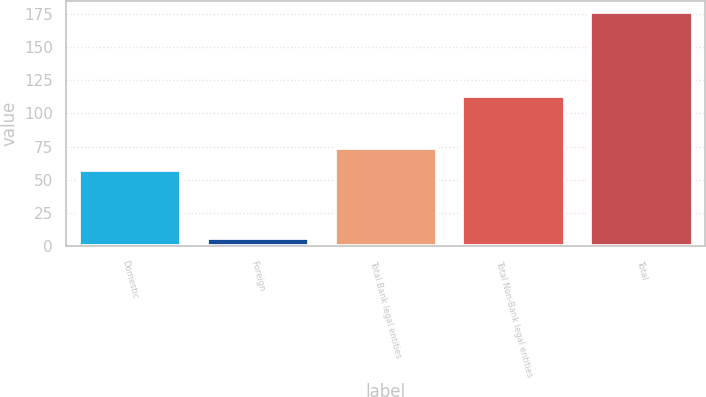Convert chart. <chart><loc_0><loc_0><loc_500><loc_500><bar_chart><fcel>Domestic<fcel>Foreign<fcel>Total Bank legal entities<fcel>Total Non-Bank legal entities<fcel>Total<nl><fcel>57<fcel>6<fcel>74<fcel>113<fcel>176<nl></chart> 